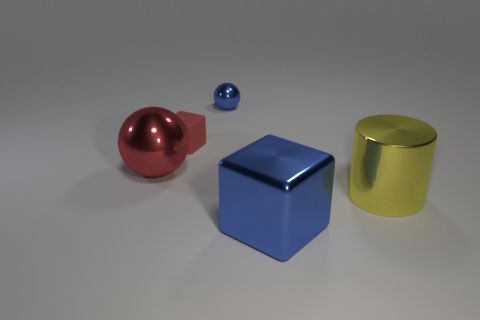Subtract all blue spheres. How many spheres are left? 1 Subtract 1 spheres. How many spheres are left? 1 Subtract all red cylinders. How many brown balls are left? 0 Subtract all gray blocks. Subtract all green cylinders. How many blocks are left? 2 Subtract all small matte spheres. Subtract all small things. How many objects are left? 3 Add 1 small blue balls. How many small blue balls are left? 2 Add 2 red matte blocks. How many red matte blocks exist? 3 Add 2 small red things. How many objects exist? 7 Subtract 1 red cubes. How many objects are left? 4 Subtract all balls. How many objects are left? 3 